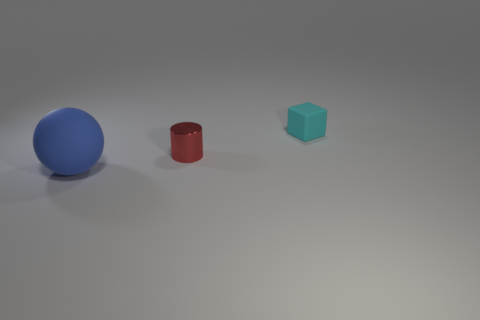Add 3 large yellow shiny cubes. How many objects exist? 6 Subtract all cylinders. How many objects are left? 2 Add 2 small blocks. How many small blocks are left? 3 Add 3 cyan matte things. How many cyan matte things exist? 4 Subtract 0 yellow cubes. How many objects are left? 3 Subtract all purple objects. Subtract all tiny cyan matte blocks. How many objects are left? 2 